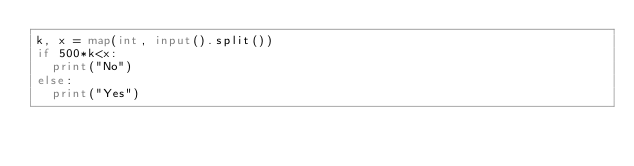Convert code to text. <code><loc_0><loc_0><loc_500><loc_500><_Python_>k, x = map(int, input().split())
if 500*k<x:
  print("No")
else:
  print("Yes")</code> 